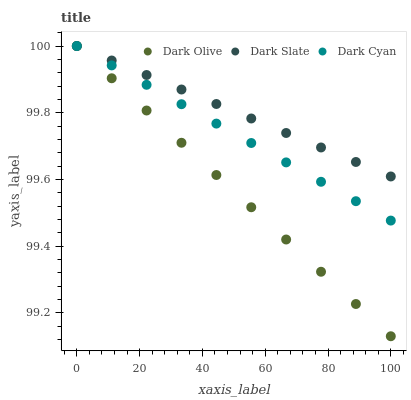Does Dark Olive have the minimum area under the curve?
Answer yes or no. Yes. Does Dark Slate have the maximum area under the curve?
Answer yes or no. Yes. Does Dark Slate have the minimum area under the curve?
Answer yes or no. No. Does Dark Olive have the maximum area under the curve?
Answer yes or no. No. Is Dark Cyan the smoothest?
Answer yes or no. Yes. Is Dark Slate the roughest?
Answer yes or no. Yes. Is Dark Olive the smoothest?
Answer yes or no. No. Is Dark Olive the roughest?
Answer yes or no. No. Does Dark Olive have the lowest value?
Answer yes or no. Yes. Does Dark Slate have the lowest value?
Answer yes or no. No. Does Dark Olive have the highest value?
Answer yes or no. Yes. Does Dark Cyan intersect Dark Olive?
Answer yes or no. Yes. Is Dark Cyan less than Dark Olive?
Answer yes or no. No. Is Dark Cyan greater than Dark Olive?
Answer yes or no. No. 